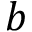<formula> <loc_0><loc_0><loc_500><loc_500>b</formula> 